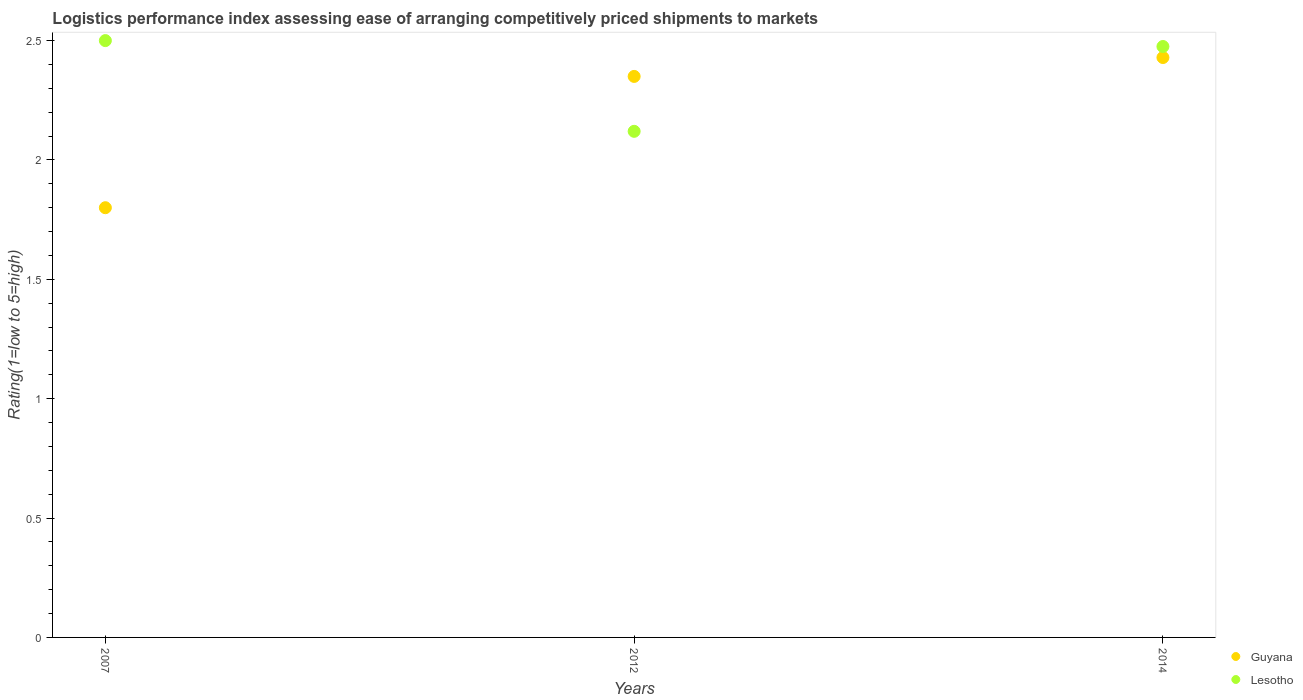Is the number of dotlines equal to the number of legend labels?
Keep it short and to the point. Yes. Across all years, what is the maximum Logistic performance index in Guyana?
Your answer should be compact. 2.43. In which year was the Logistic performance index in Lesotho maximum?
Your response must be concise. 2007. What is the total Logistic performance index in Lesotho in the graph?
Your answer should be compact. 7.1. What is the difference between the Logistic performance index in Lesotho in 2007 and that in 2012?
Offer a terse response. 0.38. What is the difference between the Logistic performance index in Guyana in 2014 and the Logistic performance index in Lesotho in 2007?
Your answer should be very brief. -0.07. What is the average Logistic performance index in Lesotho per year?
Keep it short and to the point. 2.37. In the year 2007, what is the difference between the Logistic performance index in Lesotho and Logistic performance index in Guyana?
Offer a terse response. 0.7. In how many years, is the Logistic performance index in Guyana greater than 1.4?
Offer a very short reply. 3. What is the ratio of the Logistic performance index in Lesotho in 2007 to that in 2014?
Provide a short and direct response. 1.01. Is the Logistic performance index in Lesotho in 2007 less than that in 2014?
Offer a terse response. No. What is the difference between the highest and the second highest Logistic performance index in Guyana?
Ensure brevity in your answer.  0.08. What is the difference between the highest and the lowest Logistic performance index in Lesotho?
Ensure brevity in your answer.  0.38. In how many years, is the Logistic performance index in Lesotho greater than the average Logistic performance index in Lesotho taken over all years?
Give a very brief answer. 2. Does the Logistic performance index in Guyana monotonically increase over the years?
Offer a terse response. Yes. Is the Logistic performance index in Lesotho strictly less than the Logistic performance index in Guyana over the years?
Provide a short and direct response. No. What is the difference between two consecutive major ticks on the Y-axis?
Provide a succinct answer. 0.5. Does the graph contain grids?
Ensure brevity in your answer.  No. What is the title of the graph?
Give a very brief answer. Logistics performance index assessing ease of arranging competitively priced shipments to markets. Does "Sudan" appear as one of the legend labels in the graph?
Keep it short and to the point. No. What is the label or title of the Y-axis?
Ensure brevity in your answer.  Rating(1=low to 5=high). What is the Rating(1=low to 5=high) in Lesotho in 2007?
Make the answer very short. 2.5. What is the Rating(1=low to 5=high) in Guyana in 2012?
Your response must be concise. 2.35. What is the Rating(1=low to 5=high) in Lesotho in 2012?
Provide a succinct answer. 2.12. What is the Rating(1=low to 5=high) in Guyana in 2014?
Offer a very short reply. 2.43. What is the Rating(1=low to 5=high) of Lesotho in 2014?
Offer a terse response. 2.48. Across all years, what is the maximum Rating(1=low to 5=high) in Guyana?
Ensure brevity in your answer.  2.43. Across all years, what is the minimum Rating(1=low to 5=high) in Guyana?
Ensure brevity in your answer.  1.8. Across all years, what is the minimum Rating(1=low to 5=high) of Lesotho?
Provide a succinct answer. 2.12. What is the total Rating(1=low to 5=high) of Guyana in the graph?
Provide a succinct answer. 6.58. What is the total Rating(1=low to 5=high) in Lesotho in the graph?
Make the answer very short. 7.1. What is the difference between the Rating(1=low to 5=high) in Guyana in 2007 and that in 2012?
Offer a terse response. -0.55. What is the difference between the Rating(1=low to 5=high) of Lesotho in 2007 and that in 2012?
Give a very brief answer. 0.38. What is the difference between the Rating(1=low to 5=high) of Guyana in 2007 and that in 2014?
Keep it short and to the point. -0.63. What is the difference between the Rating(1=low to 5=high) of Lesotho in 2007 and that in 2014?
Make the answer very short. 0.02. What is the difference between the Rating(1=low to 5=high) in Guyana in 2012 and that in 2014?
Keep it short and to the point. -0.08. What is the difference between the Rating(1=low to 5=high) of Lesotho in 2012 and that in 2014?
Your response must be concise. -0.36. What is the difference between the Rating(1=low to 5=high) in Guyana in 2007 and the Rating(1=low to 5=high) in Lesotho in 2012?
Your answer should be very brief. -0.32. What is the difference between the Rating(1=low to 5=high) of Guyana in 2007 and the Rating(1=low to 5=high) of Lesotho in 2014?
Offer a very short reply. -0.68. What is the difference between the Rating(1=low to 5=high) in Guyana in 2012 and the Rating(1=low to 5=high) in Lesotho in 2014?
Offer a terse response. -0.13. What is the average Rating(1=low to 5=high) in Guyana per year?
Your answer should be compact. 2.19. What is the average Rating(1=low to 5=high) in Lesotho per year?
Provide a short and direct response. 2.37. In the year 2007, what is the difference between the Rating(1=low to 5=high) in Guyana and Rating(1=low to 5=high) in Lesotho?
Provide a succinct answer. -0.7. In the year 2012, what is the difference between the Rating(1=low to 5=high) in Guyana and Rating(1=low to 5=high) in Lesotho?
Your answer should be very brief. 0.23. In the year 2014, what is the difference between the Rating(1=low to 5=high) in Guyana and Rating(1=low to 5=high) in Lesotho?
Give a very brief answer. -0.05. What is the ratio of the Rating(1=low to 5=high) in Guyana in 2007 to that in 2012?
Make the answer very short. 0.77. What is the ratio of the Rating(1=low to 5=high) of Lesotho in 2007 to that in 2012?
Offer a very short reply. 1.18. What is the ratio of the Rating(1=low to 5=high) of Guyana in 2007 to that in 2014?
Your response must be concise. 0.74. What is the ratio of the Rating(1=low to 5=high) of Guyana in 2012 to that in 2014?
Provide a succinct answer. 0.97. What is the ratio of the Rating(1=low to 5=high) of Lesotho in 2012 to that in 2014?
Ensure brevity in your answer.  0.86. What is the difference between the highest and the second highest Rating(1=low to 5=high) of Guyana?
Provide a succinct answer. 0.08. What is the difference between the highest and the second highest Rating(1=low to 5=high) of Lesotho?
Your answer should be compact. 0.02. What is the difference between the highest and the lowest Rating(1=low to 5=high) of Guyana?
Provide a short and direct response. 0.63. What is the difference between the highest and the lowest Rating(1=low to 5=high) of Lesotho?
Give a very brief answer. 0.38. 